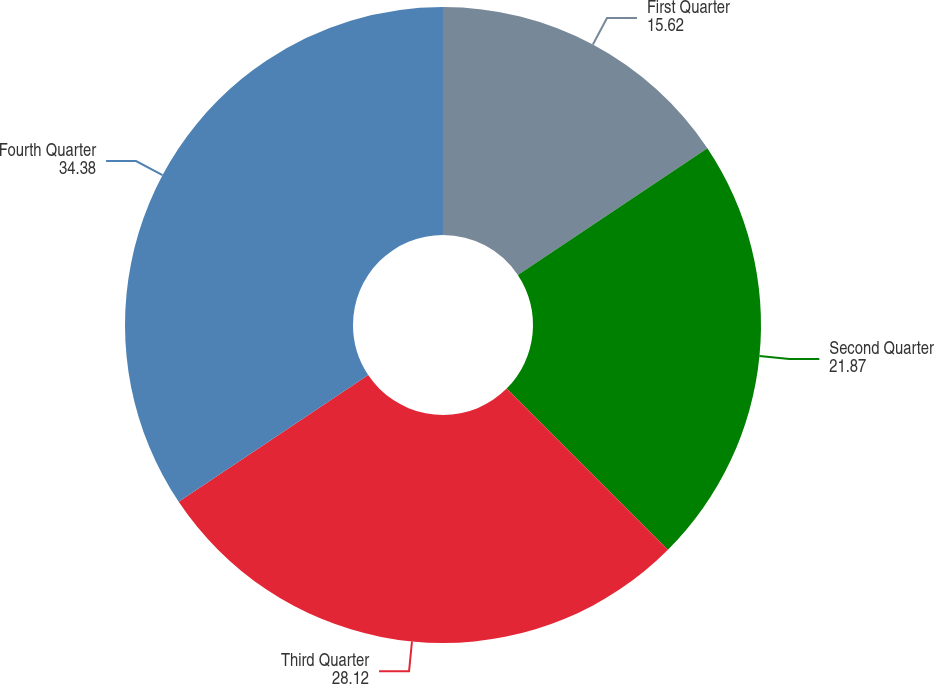Convert chart. <chart><loc_0><loc_0><loc_500><loc_500><pie_chart><fcel>First Quarter<fcel>Second Quarter<fcel>Third Quarter<fcel>Fourth Quarter<nl><fcel>15.62%<fcel>21.87%<fcel>28.12%<fcel>34.38%<nl></chart> 